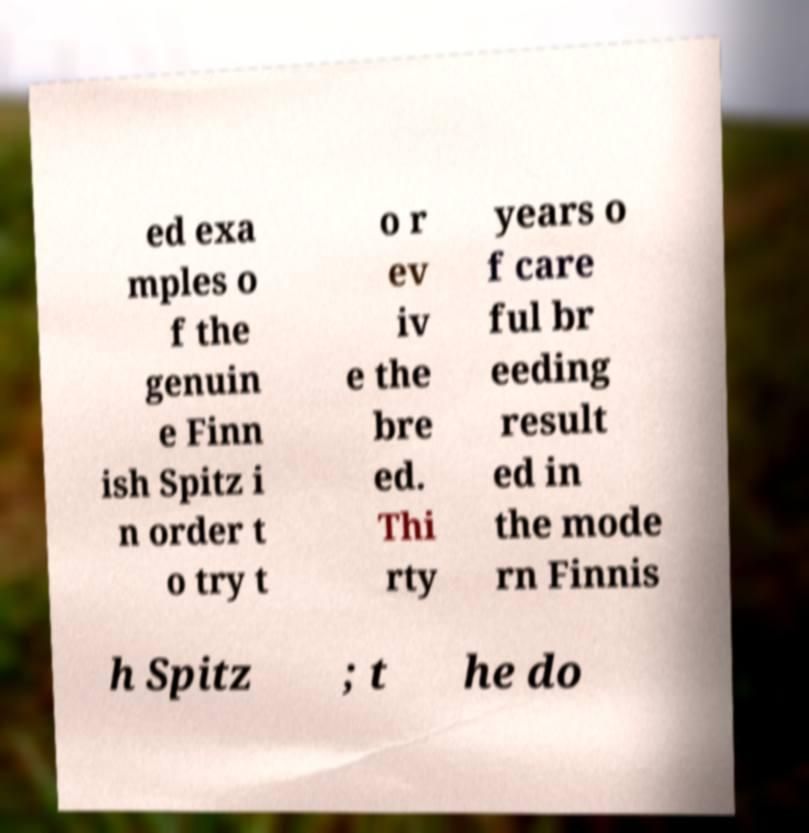Please read and relay the text visible in this image. What does it say? ed exa mples o f the genuin e Finn ish Spitz i n order t o try t o r ev iv e the bre ed. Thi rty years o f care ful br eeding result ed in the mode rn Finnis h Spitz ; t he do 